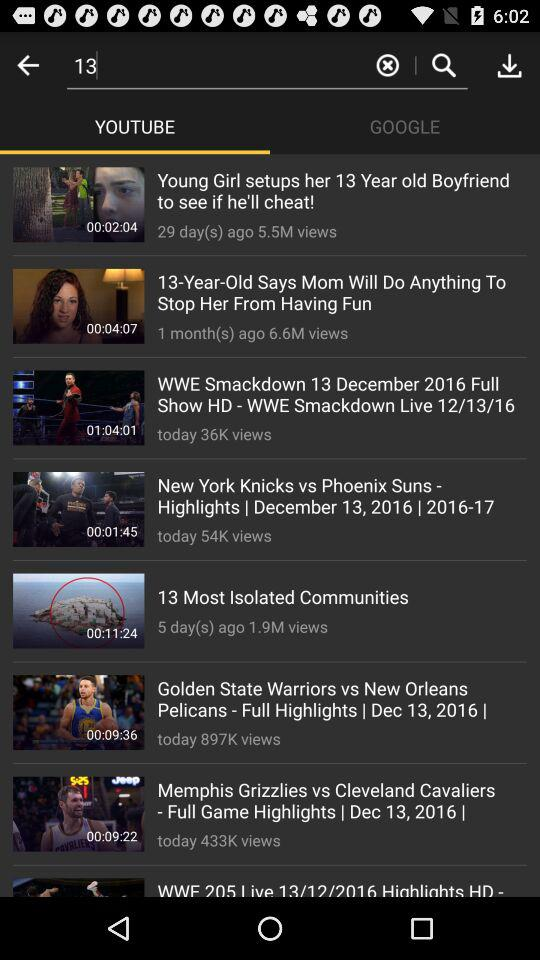How many days ago did the "13 Most Isolated Communities" video come? The video came 5 days ago. 